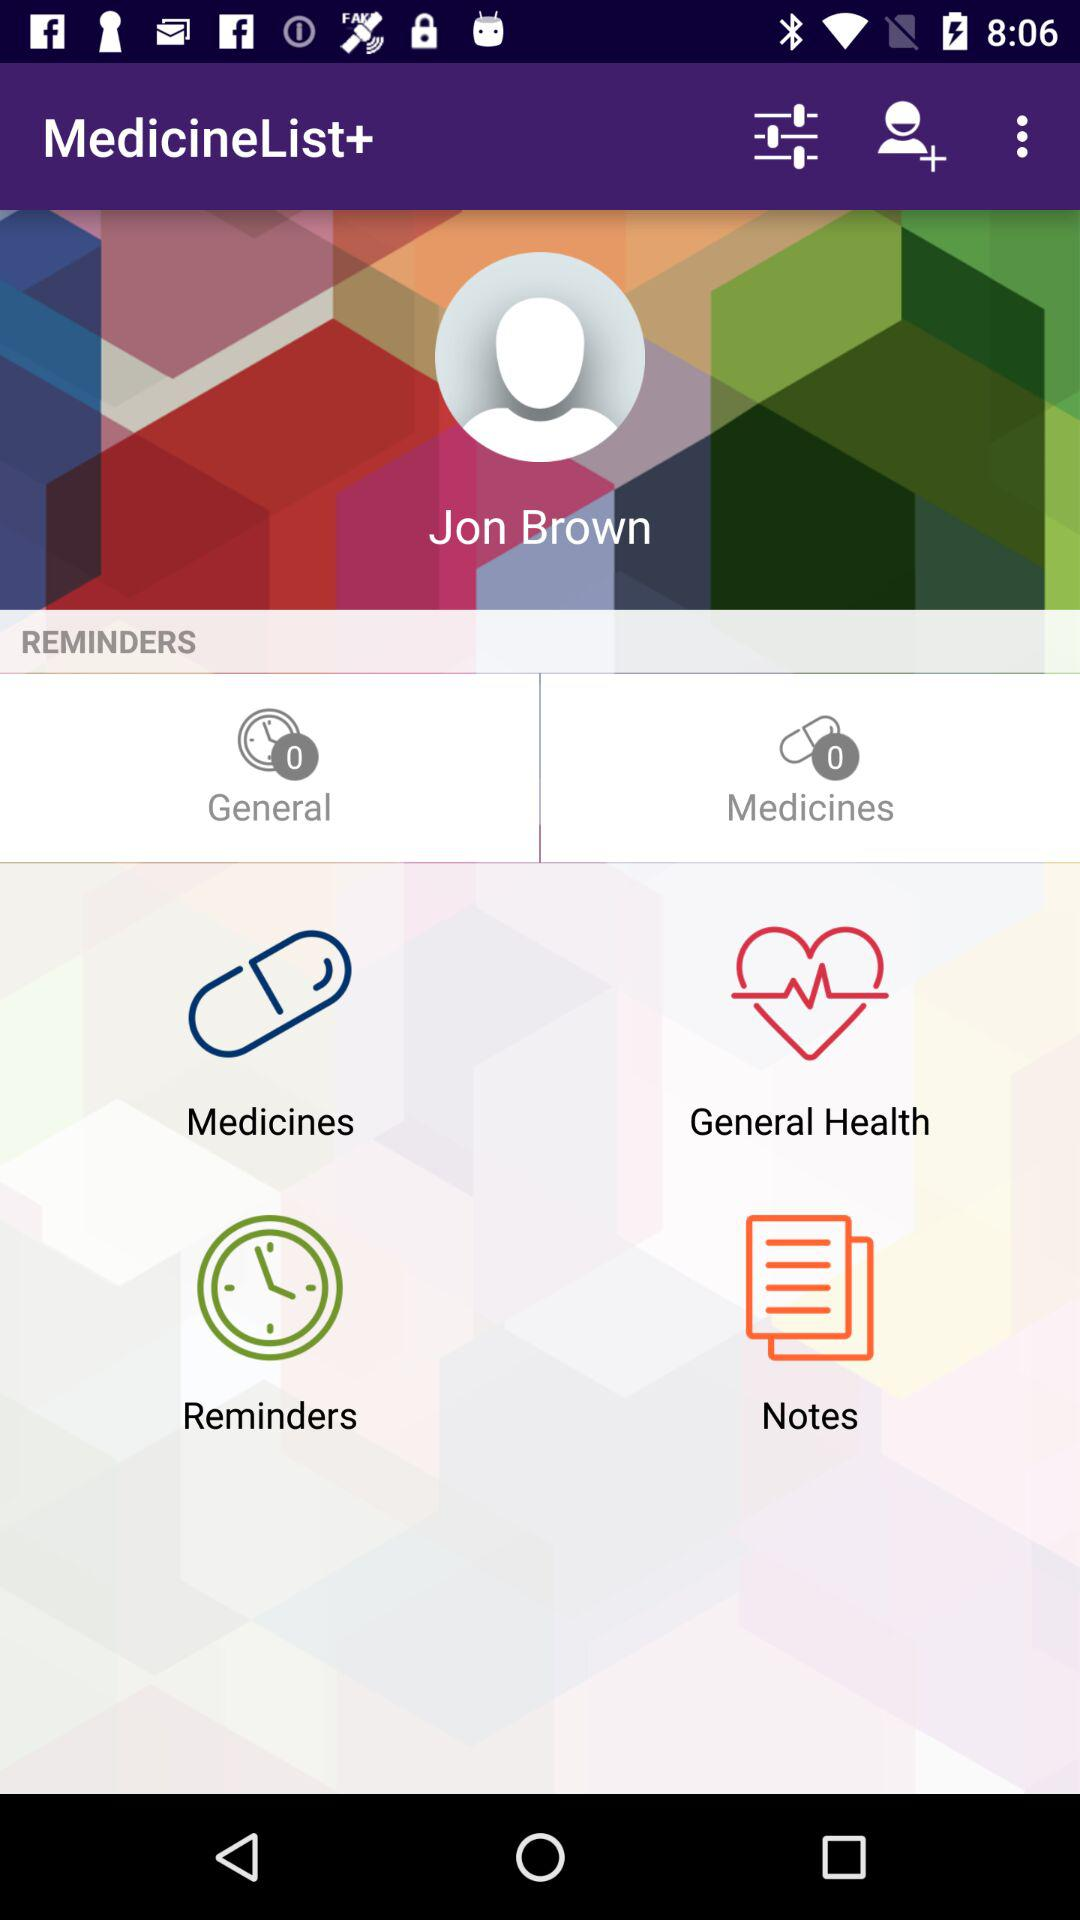What is the application name?
When the provided information is insufficient, respond with <no answer>. <no answer> 